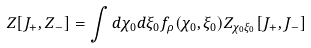<formula> <loc_0><loc_0><loc_500><loc_500>Z [ J _ { + } , Z _ { - } ] = \int d \chi _ { 0 } d \xi _ { 0 } f _ { \rho } ( \chi _ { 0 } , \xi _ { 0 } ) Z _ { \chi _ { 0 } \xi _ { 0 } } [ J _ { + } , J _ { - } ]</formula> 